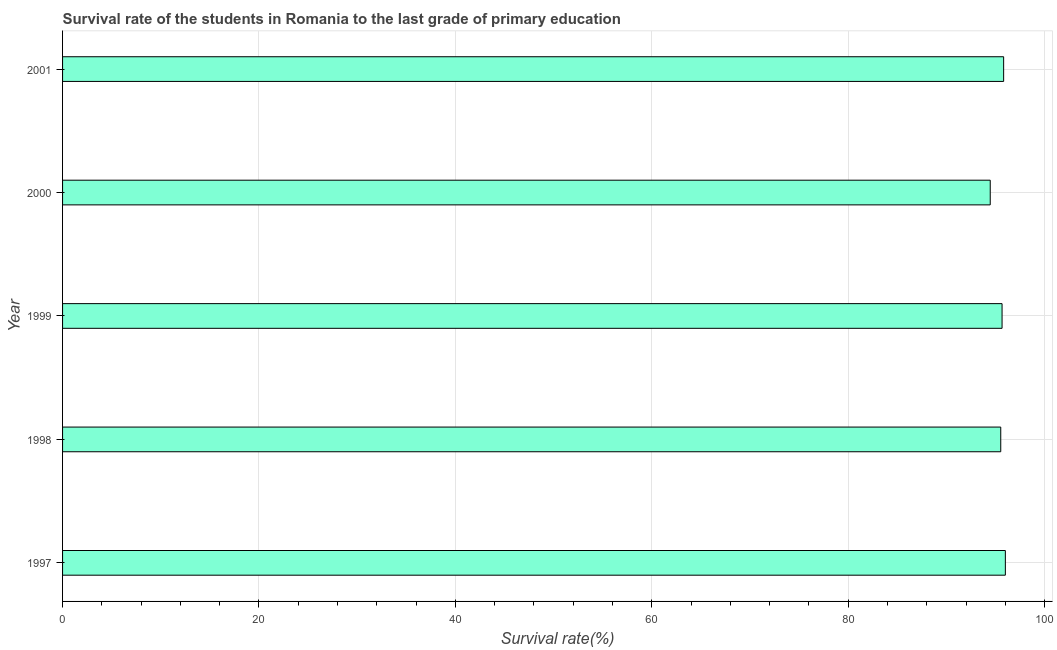Does the graph contain any zero values?
Keep it short and to the point. No. Does the graph contain grids?
Keep it short and to the point. Yes. What is the title of the graph?
Offer a terse response. Survival rate of the students in Romania to the last grade of primary education. What is the label or title of the X-axis?
Your response must be concise. Survival rate(%). What is the survival rate in primary education in 1997?
Your answer should be compact. 96. Across all years, what is the maximum survival rate in primary education?
Provide a succinct answer. 96. Across all years, what is the minimum survival rate in primary education?
Your response must be concise. 94.46. In which year was the survival rate in primary education minimum?
Ensure brevity in your answer.  2000. What is the sum of the survival rate in primary education?
Ensure brevity in your answer.  477.49. What is the difference between the survival rate in primary education in 2000 and 2001?
Your response must be concise. -1.36. What is the average survival rate in primary education per year?
Make the answer very short. 95.5. What is the median survival rate in primary education?
Provide a succinct answer. 95.67. In how many years, is the survival rate in primary education greater than 28 %?
Offer a very short reply. 5. Is the survival rate in primary education in 1997 less than that in 1999?
Provide a succinct answer. No. What is the difference between the highest and the second highest survival rate in primary education?
Your answer should be compact. 0.17. Is the sum of the survival rate in primary education in 2000 and 2001 greater than the maximum survival rate in primary education across all years?
Provide a succinct answer. Yes. What is the difference between the highest and the lowest survival rate in primary education?
Make the answer very short. 1.54. In how many years, is the survival rate in primary education greater than the average survival rate in primary education taken over all years?
Provide a succinct answer. 4. How many bars are there?
Your response must be concise. 5. How many years are there in the graph?
Keep it short and to the point. 5. Are the values on the major ticks of X-axis written in scientific E-notation?
Provide a succinct answer. No. What is the Survival rate(%) in 1997?
Provide a succinct answer. 96. What is the Survival rate(%) of 1998?
Offer a terse response. 95.53. What is the Survival rate(%) of 1999?
Keep it short and to the point. 95.67. What is the Survival rate(%) of 2000?
Ensure brevity in your answer.  94.46. What is the Survival rate(%) of 2001?
Ensure brevity in your answer.  95.83. What is the difference between the Survival rate(%) in 1997 and 1998?
Ensure brevity in your answer.  0.47. What is the difference between the Survival rate(%) in 1997 and 1999?
Give a very brief answer. 0.34. What is the difference between the Survival rate(%) in 1997 and 2000?
Offer a very short reply. 1.54. What is the difference between the Survival rate(%) in 1997 and 2001?
Provide a short and direct response. 0.17. What is the difference between the Survival rate(%) in 1998 and 1999?
Provide a succinct answer. -0.13. What is the difference between the Survival rate(%) in 1998 and 2000?
Offer a terse response. 1.07. What is the difference between the Survival rate(%) in 1998 and 2001?
Your response must be concise. -0.29. What is the difference between the Survival rate(%) in 1999 and 2000?
Offer a very short reply. 1.2. What is the difference between the Survival rate(%) in 1999 and 2001?
Offer a very short reply. -0.16. What is the difference between the Survival rate(%) in 2000 and 2001?
Offer a very short reply. -1.36. What is the ratio of the Survival rate(%) in 1997 to that in 1999?
Make the answer very short. 1. What is the ratio of the Survival rate(%) in 1997 to that in 2001?
Your answer should be compact. 1. What is the ratio of the Survival rate(%) in 1998 to that in 2000?
Offer a terse response. 1.01. What is the ratio of the Survival rate(%) in 1998 to that in 2001?
Give a very brief answer. 1. What is the ratio of the Survival rate(%) in 2000 to that in 2001?
Keep it short and to the point. 0.99. 